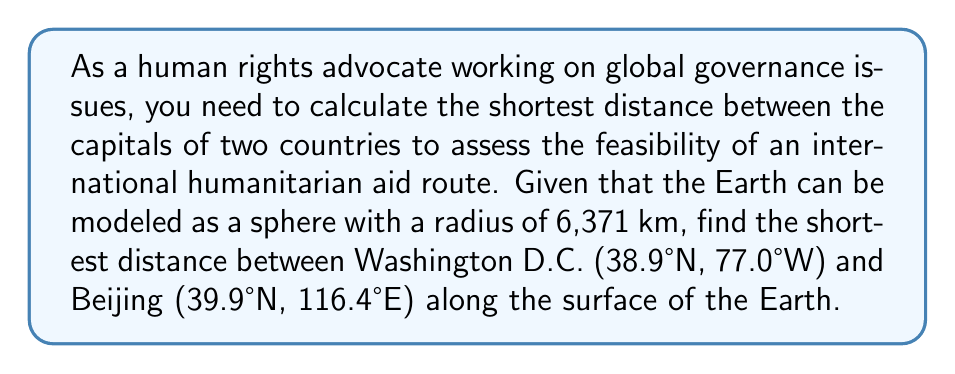Help me with this question. To solve this problem, we'll use the great circle distance formula, which gives the shortest distance between two points on a sphere. The steps are as follows:

1. Convert the latitudes and longitudes to radians:
   Washington D.C.: $\phi_1 = 38.9° \cdot \frac{\pi}{180} = 0.6790$ rad, $\lambda_1 = -77.0° \cdot \frac{\pi}{180} = -1.3439$ rad
   Beijing: $\phi_2 = 39.9° \cdot \frac{\pi}{180} = 0.6965$ rad, $\lambda_2 = 116.4° \cdot \frac{\pi}{180} = 2.0322$ rad

2. Calculate the central angle $\Delta\sigma$ using the Haversine formula:
   $$\Delta\sigma = 2 \arcsin\left(\sqrt{\sin^2\left(\frac{\phi_2 - \phi_1}{2}\right) + \cos(\phi_1)\cos(\phi_2)\sin^2\left(\frac{\lambda_2 - \lambda_1}{2}\right)}\right)$$

3. Substitute the values:
   $$\Delta\sigma = 2 \arcsin\left(\sqrt{\sin^2\left(\frac{0.6965 - 0.6790}{2}\right) + \cos(0.6790)\cos(0.6965)\sin^2\left(\frac{2.0322 - (-1.3439)}{2}\right)}\right)$$

4. Calculate the result:
   $$\Delta\sigma = 1.8835 \text{ radians}$$

5. Multiply by the Earth's radius to get the distance:
   $$d = R \cdot \Delta\sigma = 6371 \text{ km} \cdot 1.8835 = 11,999 \text{ km}$$

Thus, the shortest distance between Washington D.C. and Beijing along the surface of the Earth is approximately 11,999 km.
Answer: 11,999 km 